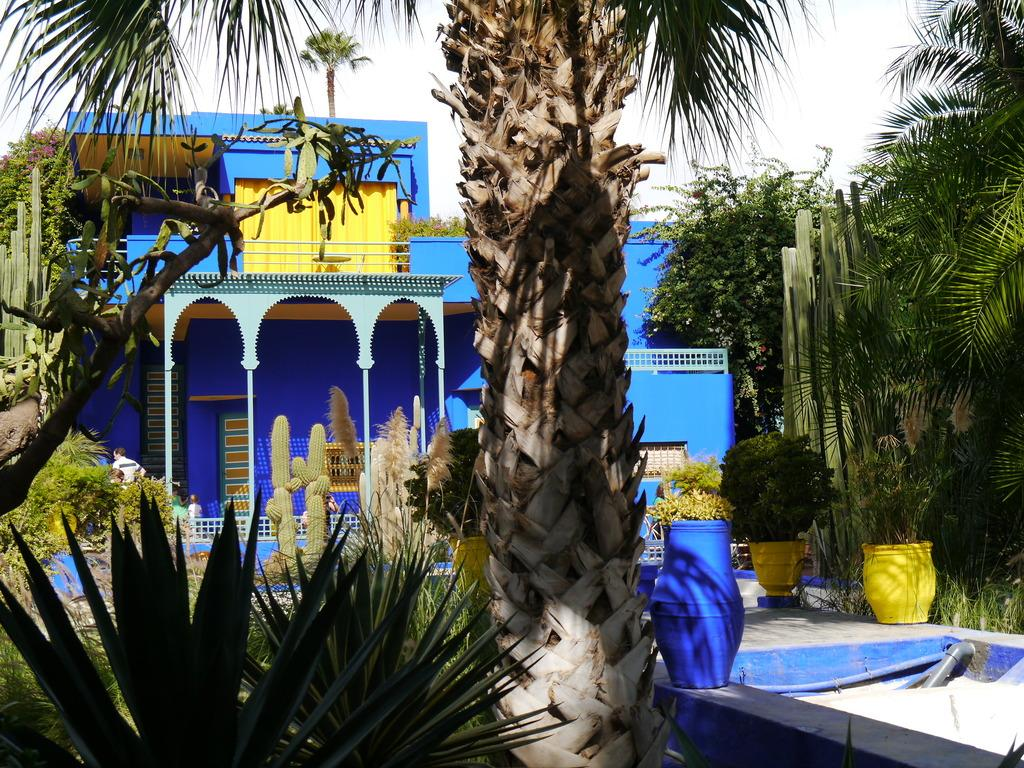What is located in the foreground of the image? There are plants and a tree in the foreground of the image. What else can be seen in the foreground of the image? There are no other objects or structures in the foreground besides the plants and tree. What is visible in the background of the image? There are trees, a house, and the sky visible in the background of the image. How many trees are visible in the foreground of the image? There is one tree visible in the foreground of the image. What type of debt is being discussed in the image? There is no mention of debt in the image; it features plants, a tree, and a background with trees, a house, and the sky. How many words are present in the image? The number of words cannot be determined from the image, as it does not contain any text or language. 